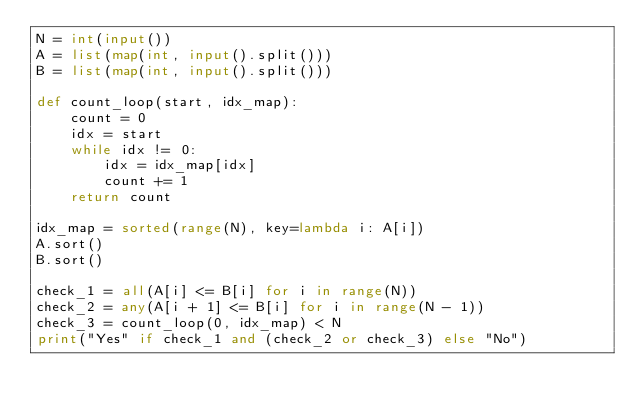Convert code to text. <code><loc_0><loc_0><loc_500><loc_500><_Python_>N = int(input())
A = list(map(int, input().split()))
B = list(map(int, input().split()))

def count_loop(start, idx_map):
    count = 0
    idx = start
    while idx != 0:
        idx = idx_map[idx]
        count += 1
    return count

idx_map = sorted(range(N), key=lambda i: A[i])
A.sort()
B.sort()

check_1 = all(A[i] <= B[i] for i in range(N))
check_2 = any(A[i + 1] <= B[i] for i in range(N - 1))
check_3 = count_loop(0, idx_map) < N
print("Yes" if check_1 and (check_2 or check_3) else "No")
</code> 